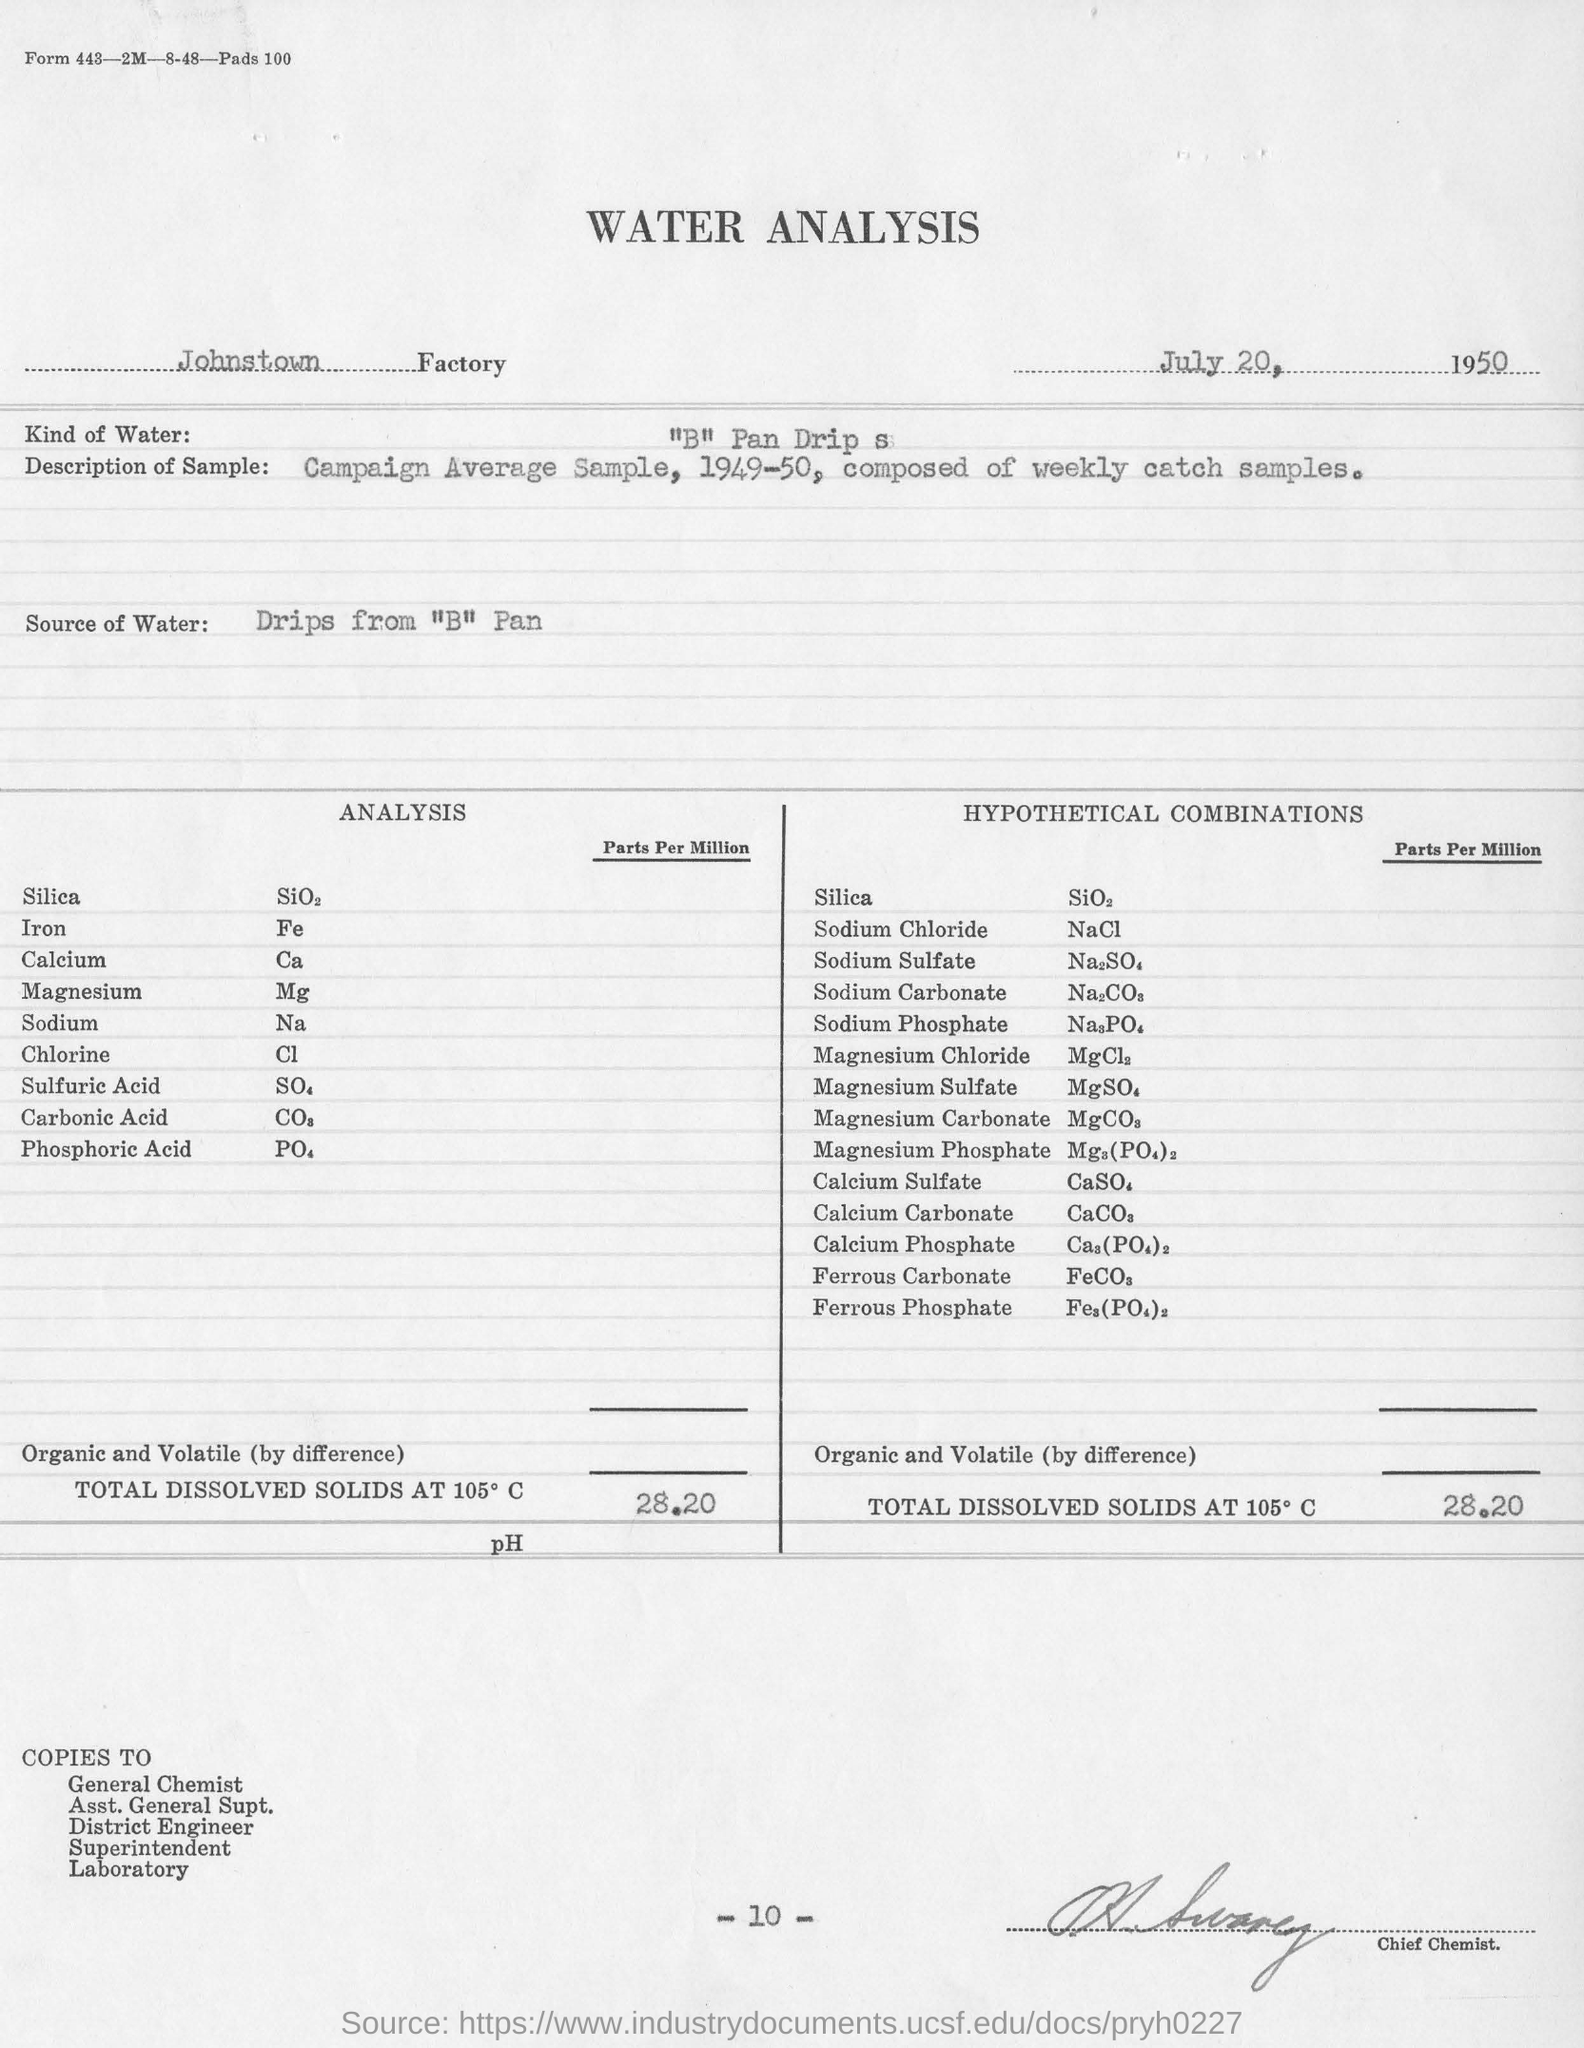What analysis is mentioned in this document?
Your answer should be compact. WATER. In which Factory is the analysis conducted?
Provide a short and direct response. Johnstown. What is the date mentioned in this document?
Ensure brevity in your answer.  July 20,  1950. What kind of water is used for analysis?
Provide a short and direct response. "B" Pan Drip s. What is the Source of Water for analysis?
Offer a terse response. Drips from "B" Pan. What is the designation of the person signed?
Provide a short and direct response. Chief Chemist. What is the page no mentioned in this document?
Ensure brevity in your answer.  -10-. 